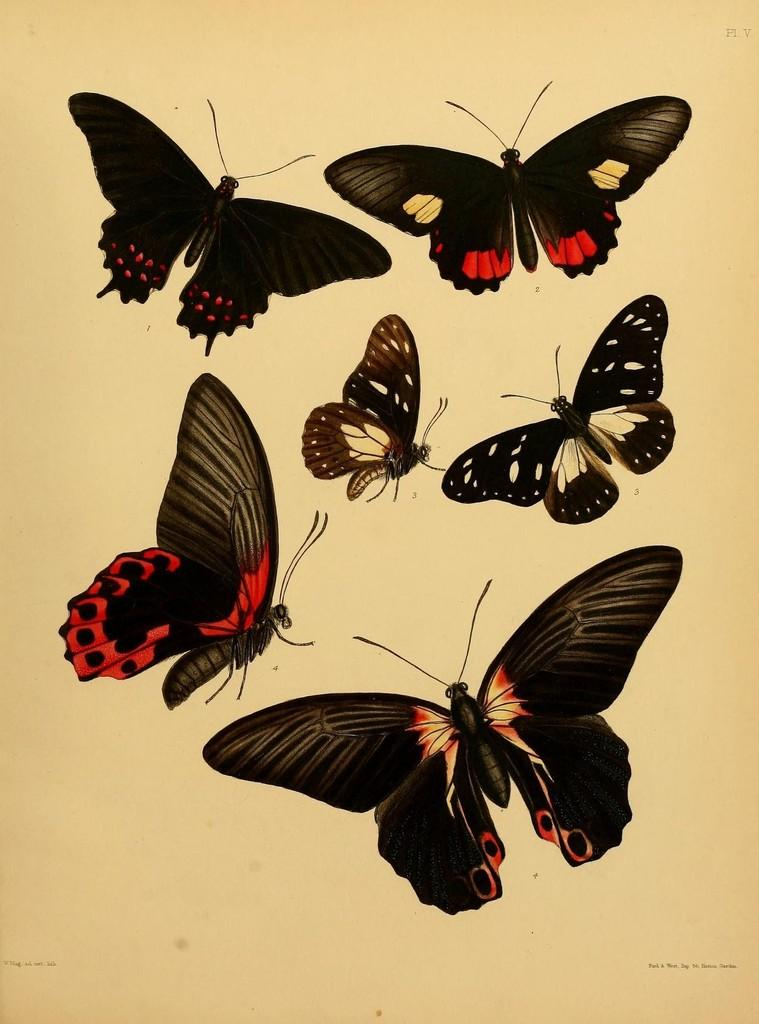What is present in the image? There is a paper in the image. What can be seen on the paper? The paper has images of butterflies on it. Where is the cave located in the image? There is no cave present in the image. What type of fish can be seen swimming near the butterflies in the image? There are no fish present in the image; it only features a paper with butterfly images. 